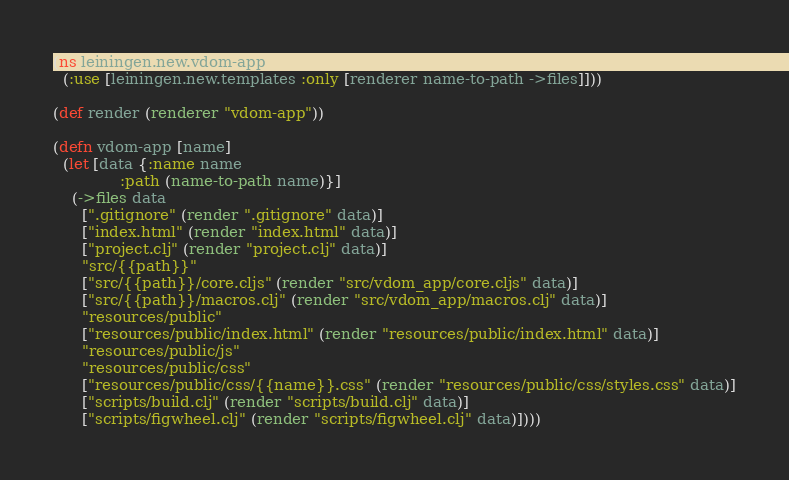<code> <loc_0><loc_0><loc_500><loc_500><_Clojure_>(ns leiningen.new.vdom-app
  (:use [leiningen.new.templates :only [renderer name-to-path ->files]]))

(def render (renderer "vdom-app"))

(defn vdom-app [name]
  (let [data {:name name
              :path (name-to-path name)}]
    (->files data
      [".gitignore" (render ".gitignore" data)]
      ["index.html" (render "index.html" data)]
      ["project.clj" (render "project.clj" data)]
      "src/{{path}}"
      ["src/{{path}}/core.cljs" (render "src/vdom_app/core.cljs" data)]
      ["src/{{path}}/macros.clj" (render "src/vdom_app/macros.clj" data)]
      "resources/public"
      ["resources/public/index.html" (render "resources/public/index.html" data)]
      "resources/public/js"
      "resources/public/css"
      ["resources/public/css/{{name}}.css" (render "resources/public/css/styles.css" data)]
      ["scripts/build.clj" (render "scripts/build.clj" data)]
      ["scripts/figwheel.clj" (render "scripts/figwheel.clj" data)])))
</code> 